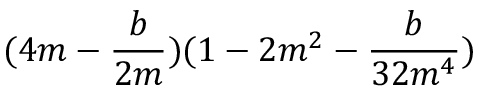Convert formula to latex. <formula><loc_0><loc_0><loc_500><loc_500>( 4 m - \frac { b } { 2 m } ) ( 1 - 2 m ^ { 2 } - \frac { b } { 3 2 m ^ { 4 } } )</formula> 